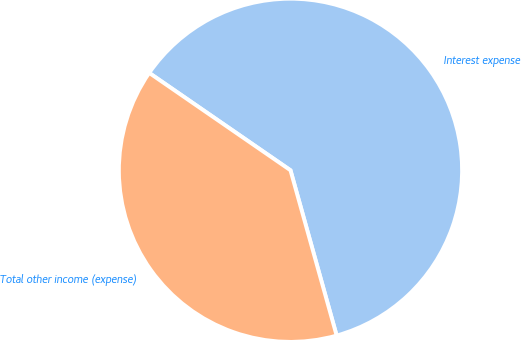Convert chart. <chart><loc_0><loc_0><loc_500><loc_500><pie_chart><fcel>Interest expense<fcel>Total other income (expense)<nl><fcel>61.06%<fcel>38.94%<nl></chart> 